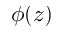<formula> <loc_0><loc_0><loc_500><loc_500>\phi ( z )</formula> 